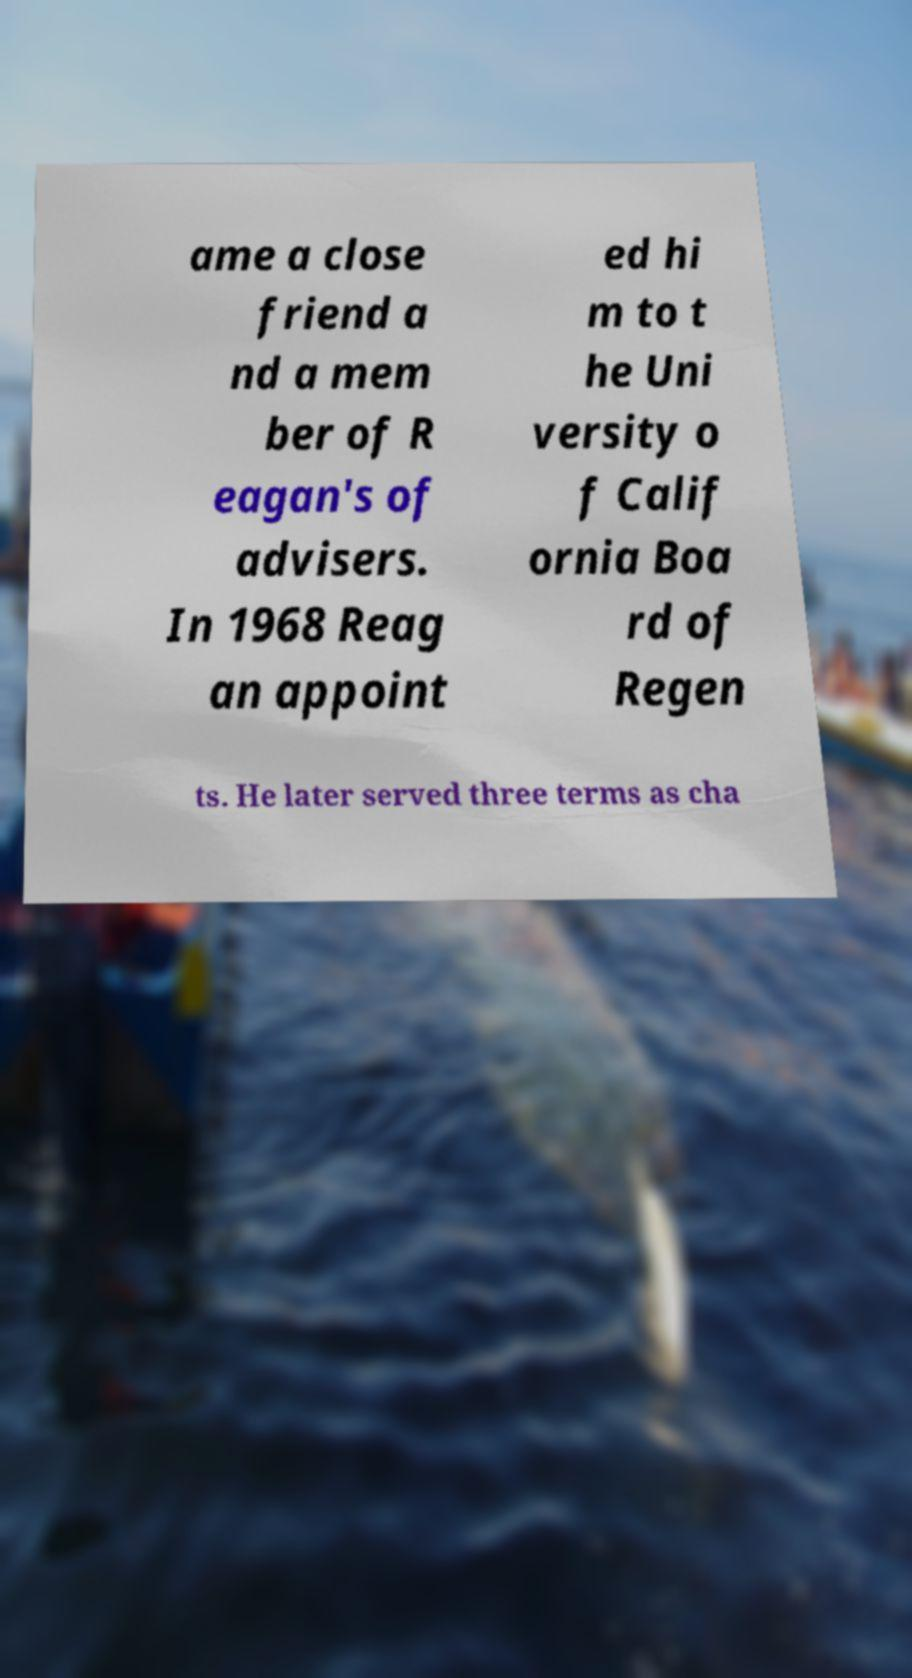Can you accurately transcribe the text from the provided image for me? ame a close friend a nd a mem ber of R eagan's of advisers. In 1968 Reag an appoint ed hi m to t he Uni versity o f Calif ornia Boa rd of Regen ts. He later served three terms as cha 